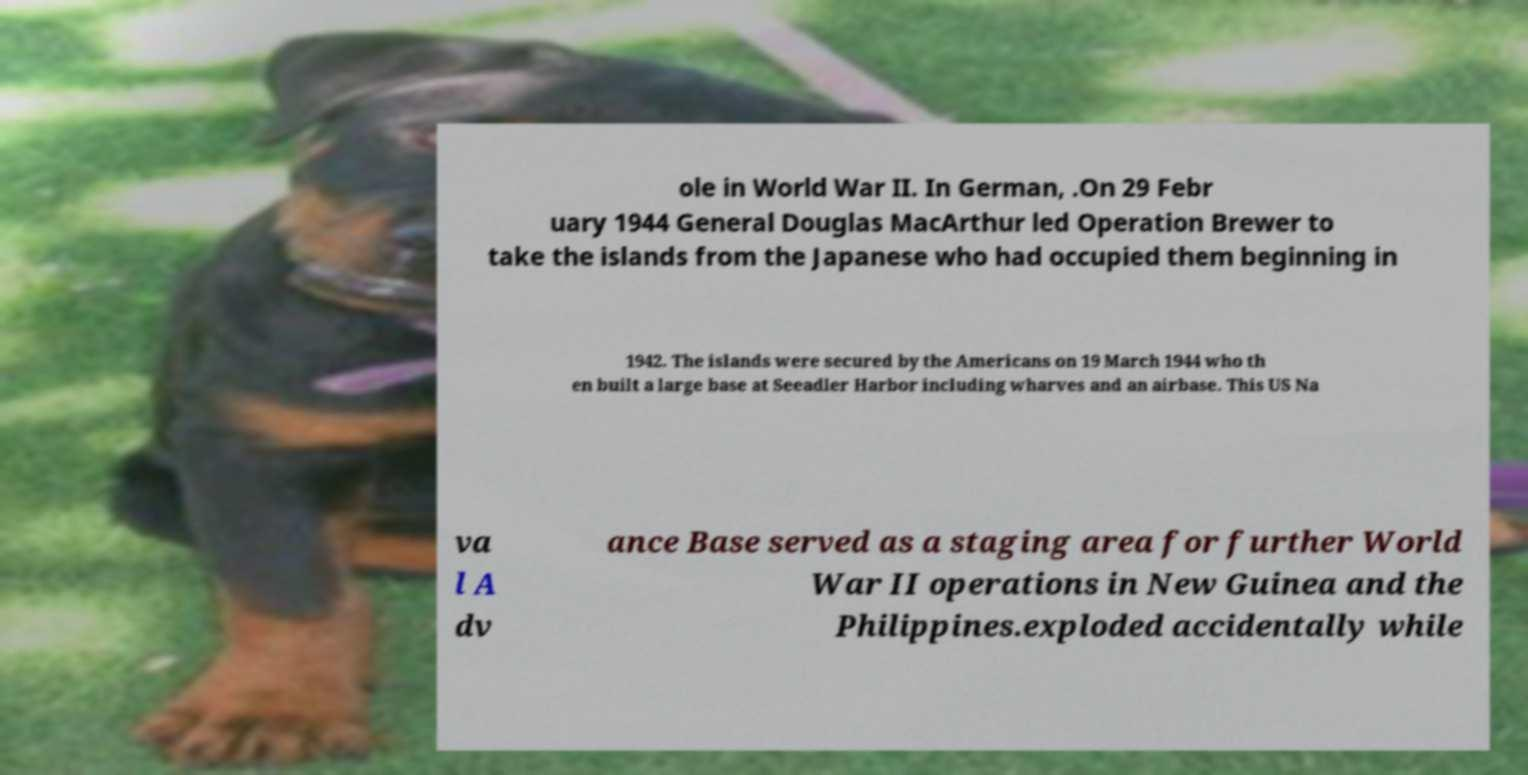Could you assist in decoding the text presented in this image and type it out clearly? ole in World War II. In German, .On 29 Febr uary 1944 General Douglas MacArthur led Operation Brewer to take the islands from the Japanese who had occupied them beginning in 1942. The islands were secured by the Americans on 19 March 1944 who th en built a large base at Seeadler Harbor including wharves and an airbase. This US Na va l A dv ance Base served as a staging area for further World War II operations in New Guinea and the Philippines.exploded accidentally while 